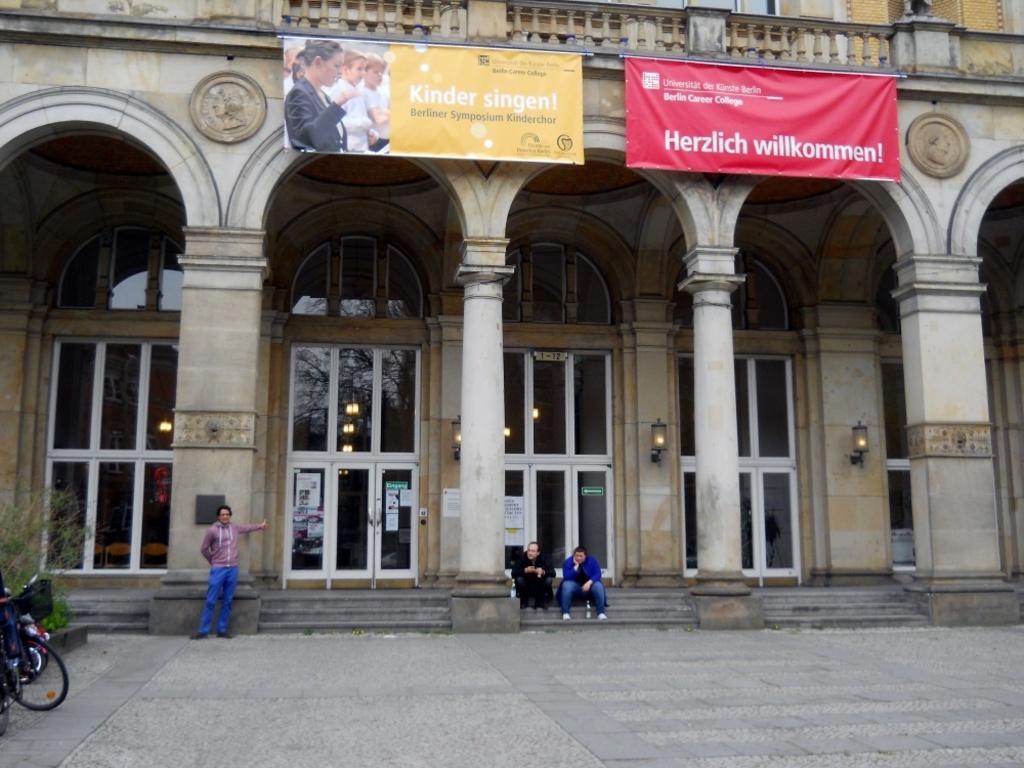How would you summarize this image in a sentence or two? There are three persons. Here we can see a bicycle, plant, banners, lights, posters, doors, and pillars. In the background there is a building. 